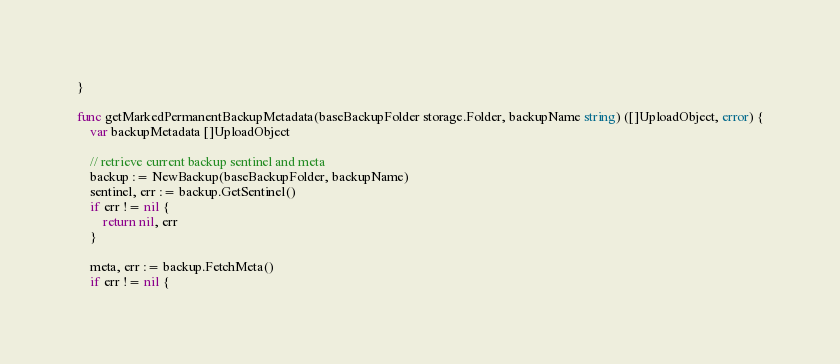<code> <loc_0><loc_0><loc_500><loc_500><_Go_>}

func getMarkedPermanentBackupMetadata(baseBackupFolder storage.Folder, backupName string) ([]UploadObject, error) {
	var backupMetadata []UploadObject

	// retrieve current backup sentinel and meta
	backup := NewBackup(baseBackupFolder, backupName)
	sentinel, err := backup.GetSentinel()
	if err != nil {
		return nil, err
	}

	meta, err := backup.FetchMeta()
	if err != nil {</code> 